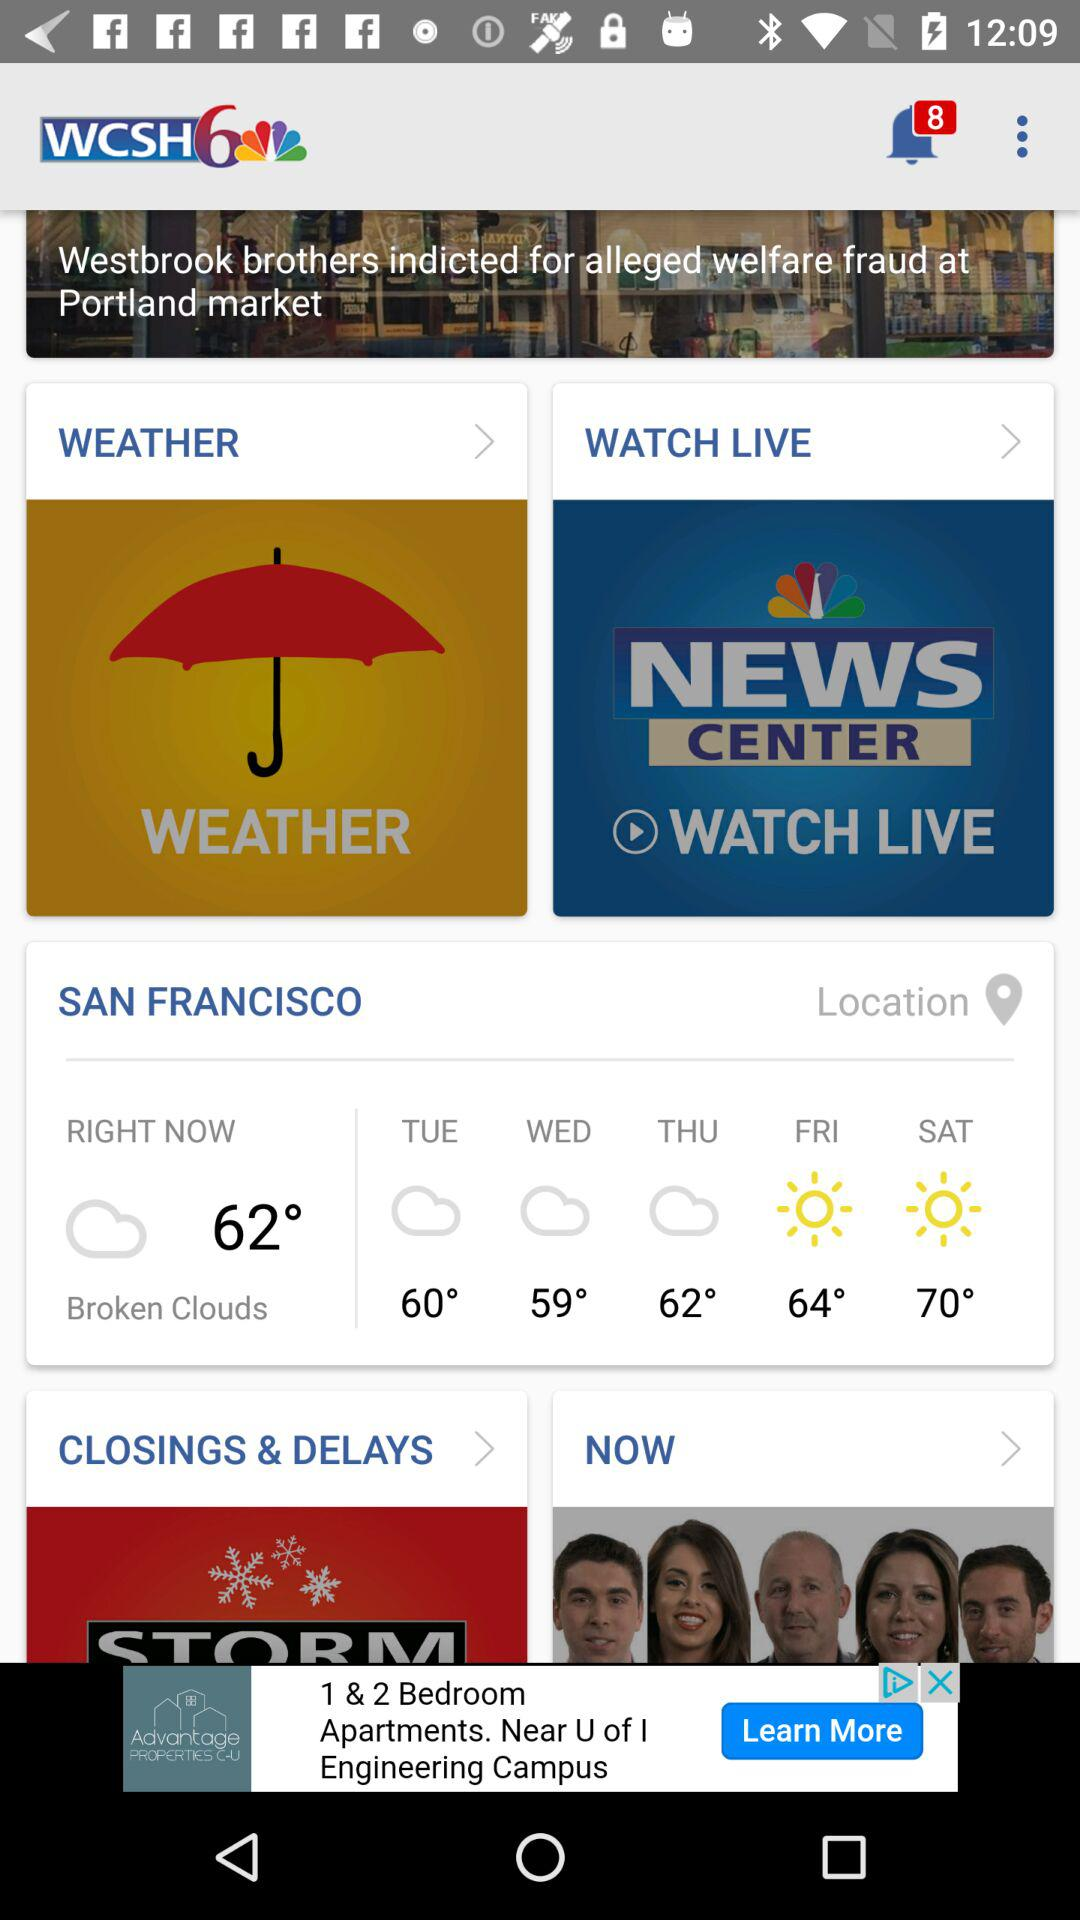What will the temperature be on Saturday? The temperature will be 70° on Saturday. 